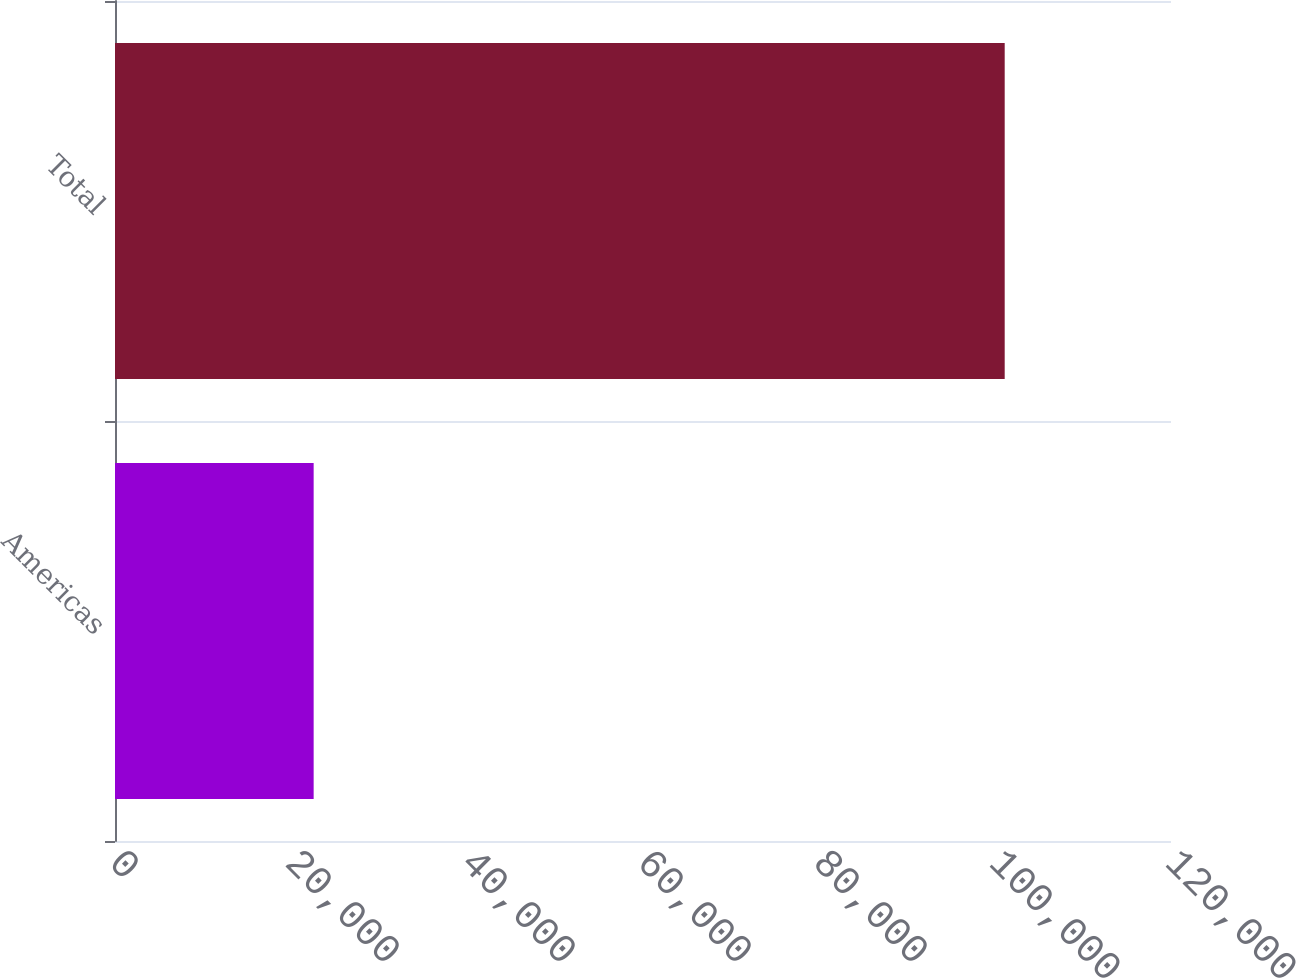Convert chart to OTSL. <chart><loc_0><loc_0><loc_500><loc_500><bar_chart><fcel>Americas<fcel>Total<nl><fcel>22574<fcel>101102<nl></chart> 